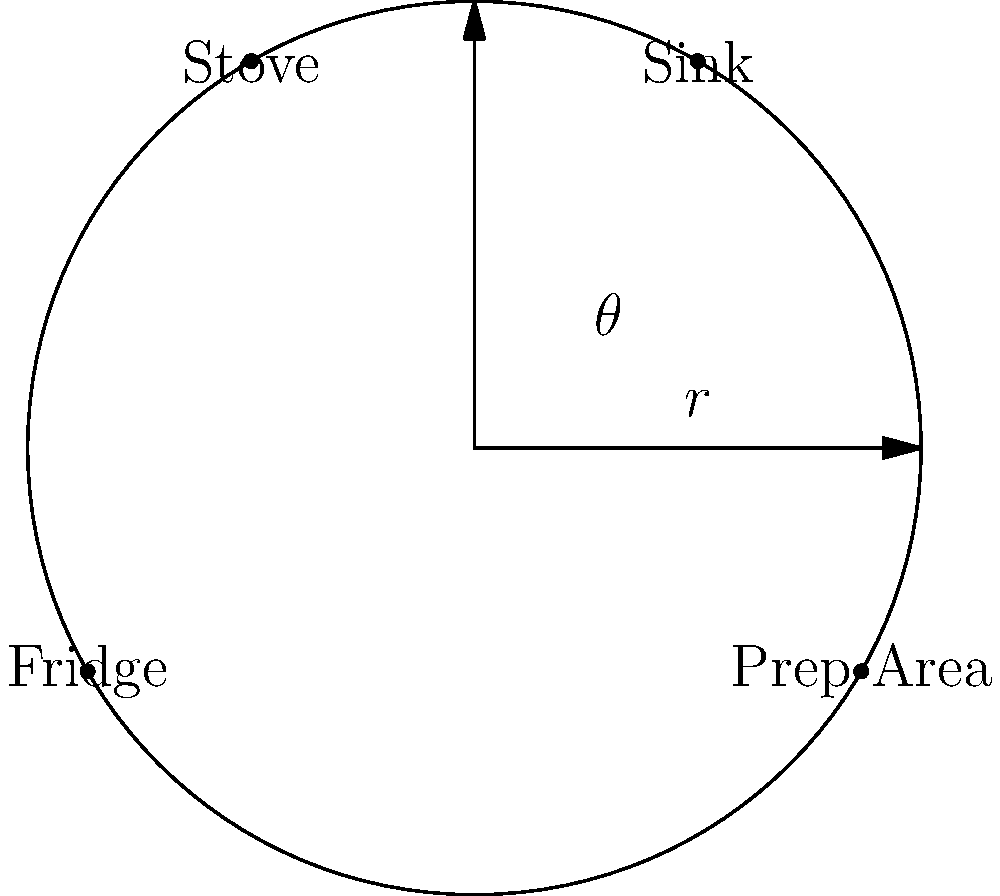In your kitchen layout represented by this polar coordinate system, the sink is located at $(r,\theta) = (5,\frac{\pi}{3})$. If you want to minimize movement between the sink and the prep area for efficient meal preparation, where should you position the prep area? To minimize movement between the sink and the prep area, we should position the prep area opposite to the sink in the polar coordinate system. This will ensure the shortest distance between these two key areas in the kitchen.

Step 1: Identify the sink's position
The sink is at $(r,\theta) = (5,\frac{\pi}{3})$, which is equivalent to $(5,60°)$.

Step 2: Determine the opposite position
To find the opposite position, we need to add $\pi$ radians (or 180°) to the sink's angle:
$\theta_{prep} = \frac{\pi}{3} + \pi = \frac{4\pi}{3}$ (or 240°)

Step 3: Keep the same radius
The radius should remain the same as the sink's position to maintain the circular layout:
$r_{prep} = 5$

Step 4: Express the final position
The prep area should be positioned at $(r,\theta) = (5,\frac{4\pi}{3})$.

This arrangement allows for the most efficient movement between the sink and prep area, optimizing the kitchen layout for quick and easy meal preparation.
Answer: $(5,\frac{4\pi}{3})$ 